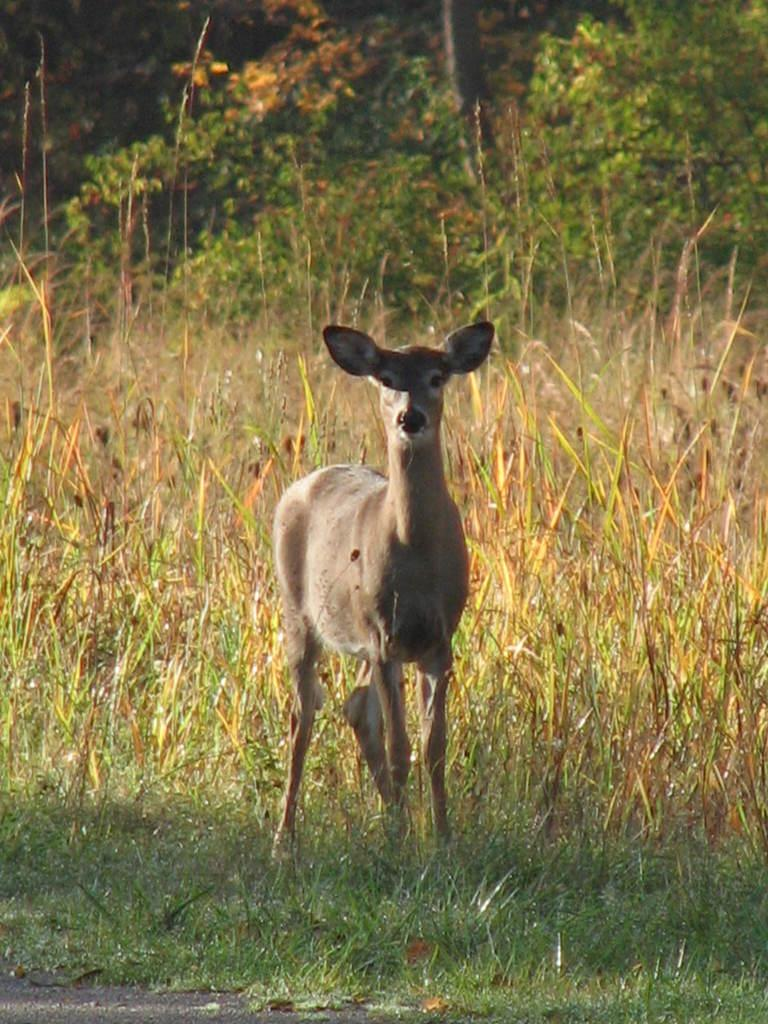What type of vegetation is in the foreground of the picture? There is grass in the foreground of the picture. What animal can be seen in the foreground of the picture? There is a deer in the foreground of the picture. What can be seen in the background of the picture? There are plants and trees in the background of the picture. What type of suit is the deer wearing in the picture? There is no suit present in the picture; the deer is a wild animal and does not wear clothing. Can you hear the crow cawing in the background of the picture? There is no mention of a crow in the provided facts, so it cannot be determined if one is present or if it is making any noise. 